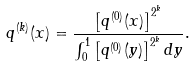<formula> <loc_0><loc_0><loc_500><loc_500>q ^ { ( k ) } ( x ) = \frac { \left [ q ^ { ( 0 ) } ( x ) \right ] ^ { 2 ^ { k } } } { \int _ { 0 } ^ { 1 } \left [ q ^ { ( 0 ) } ( y ) \right ] ^ { 2 ^ { k } } d y } .</formula> 